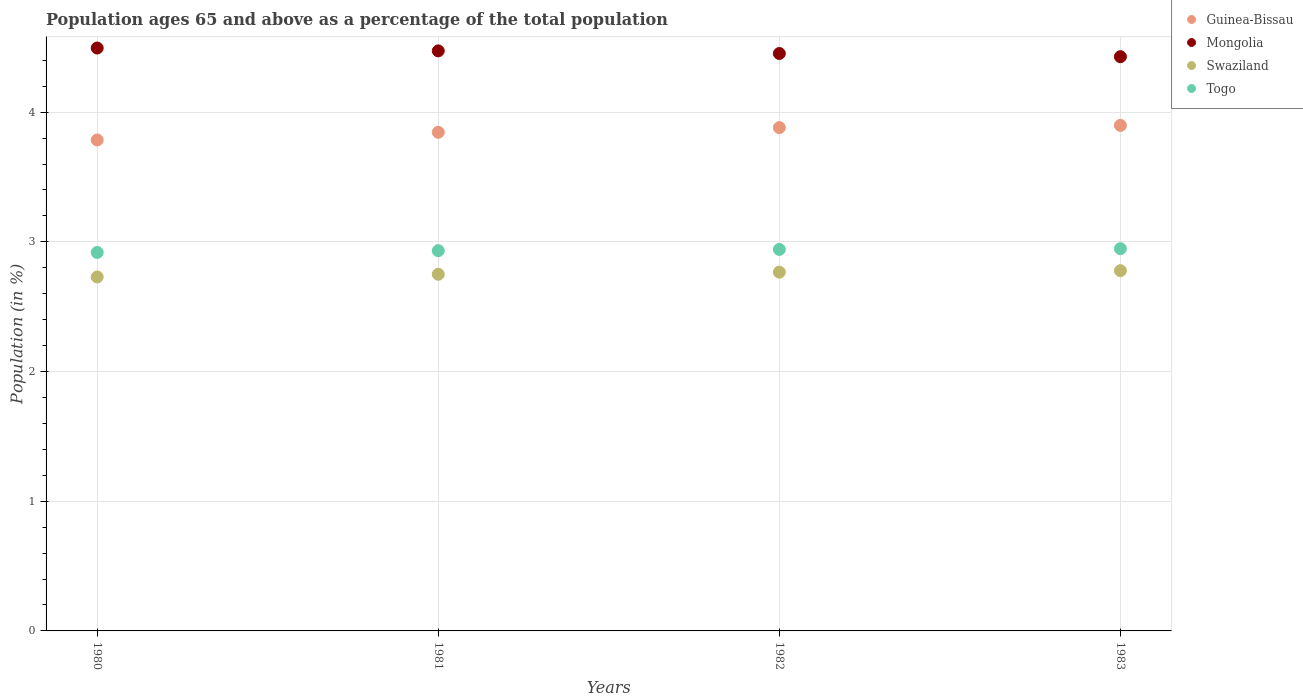What is the percentage of the population ages 65 and above in Togo in 1983?
Your answer should be compact. 2.95. Across all years, what is the maximum percentage of the population ages 65 and above in Swaziland?
Give a very brief answer. 2.78. Across all years, what is the minimum percentage of the population ages 65 and above in Guinea-Bissau?
Offer a terse response. 3.79. In which year was the percentage of the population ages 65 and above in Guinea-Bissau maximum?
Make the answer very short. 1983. In which year was the percentage of the population ages 65 and above in Togo minimum?
Provide a succinct answer. 1980. What is the total percentage of the population ages 65 and above in Togo in the graph?
Offer a very short reply. 11.74. What is the difference between the percentage of the population ages 65 and above in Togo in 1980 and that in 1981?
Your answer should be compact. -0.01. What is the difference between the percentage of the population ages 65 and above in Guinea-Bissau in 1981 and the percentage of the population ages 65 and above in Mongolia in 1982?
Your answer should be compact. -0.61. What is the average percentage of the population ages 65 and above in Swaziland per year?
Give a very brief answer. 2.76. In the year 1980, what is the difference between the percentage of the population ages 65 and above in Swaziland and percentage of the population ages 65 and above in Togo?
Keep it short and to the point. -0.19. In how many years, is the percentage of the population ages 65 and above in Guinea-Bissau greater than 2.8?
Your answer should be compact. 4. What is the ratio of the percentage of the population ages 65 and above in Mongolia in 1980 to that in 1982?
Offer a terse response. 1.01. What is the difference between the highest and the second highest percentage of the population ages 65 and above in Swaziland?
Your answer should be very brief. 0.01. What is the difference between the highest and the lowest percentage of the population ages 65 and above in Swaziland?
Your response must be concise. 0.05. Is it the case that in every year, the sum of the percentage of the population ages 65 and above in Guinea-Bissau and percentage of the population ages 65 and above in Swaziland  is greater than the sum of percentage of the population ages 65 and above in Mongolia and percentage of the population ages 65 and above in Togo?
Your answer should be compact. Yes. Is it the case that in every year, the sum of the percentage of the population ages 65 and above in Mongolia and percentage of the population ages 65 and above in Swaziland  is greater than the percentage of the population ages 65 and above in Guinea-Bissau?
Make the answer very short. Yes. Does the percentage of the population ages 65 and above in Mongolia monotonically increase over the years?
Provide a short and direct response. No. Is the percentage of the population ages 65 and above in Swaziland strictly less than the percentage of the population ages 65 and above in Mongolia over the years?
Your response must be concise. Yes. Are the values on the major ticks of Y-axis written in scientific E-notation?
Provide a short and direct response. No. What is the title of the graph?
Offer a terse response. Population ages 65 and above as a percentage of the total population. What is the label or title of the X-axis?
Offer a terse response. Years. What is the label or title of the Y-axis?
Ensure brevity in your answer.  Population (in %). What is the Population (in %) of Guinea-Bissau in 1980?
Give a very brief answer. 3.79. What is the Population (in %) in Mongolia in 1980?
Provide a short and direct response. 4.49. What is the Population (in %) in Swaziland in 1980?
Offer a terse response. 2.73. What is the Population (in %) in Togo in 1980?
Offer a very short reply. 2.92. What is the Population (in %) of Guinea-Bissau in 1981?
Make the answer very short. 3.84. What is the Population (in %) in Mongolia in 1981?
Your answer should be very brief. 4.47. What is the Population (in %) of Swaziland in 1981?
Provide a succinct answer. 2.75. What is the Population (in %) of Togo in 1981?
Your answer should be compact. 2.93. What is the Population (in %) in Guinea-Bissau in 1982?
Give a very brief answer. 3.88. What is the Population (in %) in Mongolia in 1982?
Make the answer very short. 4.45. What is the Population (in %) in Swaziland in 1982?
Your answer should be compact. 2.77. What is the Population (in %) of Togo in 1982?
Offer a terse response. 2.94. What is the Population (in %) in Guinea-Bissau in 1983?
Your response must be concise. 3.9. What is the Population (in %) in Mongolia in 1983?
Keep it short and to the point. 4.43. What is the Population (in %) in Swaziland in 1983?
Provide a succinct answer. 2.78. What is the Population (in %) in Togo in 1983?
Your response must be concise. 2.95. Across all years, what is the maximum Population (in %) of Guinea-Bissau?
Offer a very short reply. 3.9. Across all years, what is the maximum Population (in %) of Mongolia?
Keep it short and to the point. 4.49. Across all years, what is the maximum Population (in %) in Swaziland?
Ensure brevity in your answer.  2.78. Across all years, what is the maximum Population (in %) in Togo?
Keep it short and to the point. 2.95. Across all years, what is the minimum Population (in %) of Guinea-Bissau?
Offer a terse response. 3.79. Across all years, what is the minimum Population (in %) of Mongolia?
Keep it short and to the point. 4.43. Across all years, what is the minimum Population (in %) in Swaziland?
Give a very brief answer. 2.73. Across all years, what is the minimum Population (in %) in Togo?
Make the answer very short. 2.92. What is the total Population (in %) in Guinea-Bissau in the graph?
Ensure brevity in your answer.  15.41. What is the total Population (in %) of Mongolia in the graph?
Offer a terse response. 17.85. What is the total Population (in %) in Swaziland in the graph?
Your answer should be very brief. 11.02. What is the total Population (in %) in Togo in the graph?
Offer a very short reply. 11.74. What is the difference between the Population (in %) in Guinea-Bissau in 1980 and that in 1981?
Your answer should be compact. -0.06. What is the difference between the Population (in %) of Mongolia in 1980 and that in 1981?
Make the answer very short. 0.02. What is the difference between the Population (in %) in Swaziland in 1980 and that in 1981?
Your response must be concise. -0.02. What is the difference between the Population (in %) in Togo in 1980 and that in 1981?
Offer a very short reply. -0.01. What is the difference between the Population (in %) of Guinea-Bissau in 1980 and that in 1982?
Provide a short and direct response. -0.1. What is the difference between the Population (in %) of Mongolia in 1980 and that in 1982?
Your response must be concise. 0.04. What is the difference between the Population (in %) in Swaziland in 1980 and that in 1982?
Your answer should be very brief. -0.04. What is the difference between the Population (in %) in Togo in 1980 and that in 1982?
Ensure brevity in your answer.  -0.02. What is the difference between the Population (in %) in Guinea-Bissau in 1980 and that in 1983?
Provide a succinct answer. -0.11. What is the difference between the Population (in %) in Mongolia in 1980 and that in 1983?
Ensure brevity in your answer.  0.07. What is the difference between the Population (in %) in Swaziland in 1980 and that in 1983?
Your answer should be compact. -0.05. What is the difference between the Population (in %) in Togo in 1980 and that in 1983?
Make the answer very short. -0.03. What is the difference between the Population (in %) of Guinea-Bissau in 1981 and that in 1982?
Your answer should be compact. -0.04. What is the difference between the Population (in %) in Mongolia in 1981 and that in 1982?
Keep it short and to the point. 0.02. What is the difference between the Population (in %) of Swaziland in 1981 and that in 1982?
Your answer should be compact. -0.02. What is the difference between the Population (in %) of Togo in 1981 and that in 1982?
Give a very brief answer. -0.01. What is the difference between the Population (in %) in Guinea-Bissau in 1981 and that in 1983?
Keep it short and to the point. -0.05. What is the difference between the Population (in %) in Mongolia in 1981 and that in 1983?
Offer a very short reply. 0.04. What is the difference between the Population (in %) of Swaziland in 1981 and that in 1983?
Your answer should be very brief. -0.03. What is the difference between the Population (in %) of Togo in 1981 and that in 1983?
Provide a short and direct response. -0.02. What is the difference between the Population (in %) of Guinea-Bissau in 1982 and that in 1983?
Offer a terse response. -0.02. What is the difference between the Population (in %) in Mongolia in 1982 and that in 1983?
Your answer should be compact. 0.02. What is the difference between the Population (in %) in Swaziland in 1982 and that in 1983?
Make the answer very short. -0.01. What is the difference between the Population (in %) in Togo in 1982 and that in 1983?
Provide a succinct answer. -0.01. What is the difference between the Population (in %) in Guinea-Bissau in 1980 and the Population (in %) in Mongolia in 1981?
Your answer should be compact. -0.69. What is the difference between the Population (in %) of Guinea-Bissau in 1980 and the Population (in %) of Swaziland in 1981?
Your answer should be very brief. 1.04. What is the difference between the Population (in %) of Guinea-Bissau in 1980 and the Population (in %) of Togo in 1981?
Give a very brief answer. 0.85. What is the difference between the Population (in %) in Mongolia in 1980 and the Population (in %) in Swaziland in 1981?
Offer a terse response. 1.74. What is the difference between the Population (in %) of Mongolia in 1980 and the Population (in %) of Togo in 1981?
Your answer should be very brief. 1.56. What is the difference between the Population (in %) in Swaziland in 1980 and the Population (in %) in Togo in 1981?
Your response must be concise. -0.2. What is the difference between the Population (in %) in Guinea-Bissau in 1980 and the Population (in %) in Mongolia in 1982?
Offer a very short reply. -0.67. What is the difference between the Population (in %) of Guinea-Bissau in 1980 and the Population (in %) of Swaziland in 1982?
Your response must be concise. 1.02. What is the difference between the Population (in %) of Guinea-Bissau in 1980 and the Population (in %) of Togo in 1982?
Keep it short and to the point. 0.84. What is the difference between the Population (in %) in Mongolia in 1980 and the Population (in %) in Swaziland in 1982?
Give a very brief answer. 1.73. What is the difference between the Population (in %) of Mongolia in 1980 and the Population (in %) of Togo in 1982?
Provide a succinct answer. 1.55. What is the difference between the Population (in %) in Swaziland in 1980 and the Population (in %) in Togo in 1982?
Ensure brevity in your answer.  -0.21. What is the difference between the Population (in %) of Guinea-Bissau in 1980 and the Population (in %) of Mongolia in 1983?
Give a very brief answer. -0.64. What is the difference between the Population (in %) in Guinea-Bissau in 1980 and the Population (in %) in Swaziland in 1983?
Offer a very short reply. 1.01. What is the difference between the Population (in %) of Guinea-Bissau in 1980 and the Population (in %) of Togo in 1983?
Give a very brief answer. 0.84. What is the difference between the Population (in %) of Mongolia in 1980 and the Population (in %) of Swaziland in 1983?
Keep it short and to the point. 1.72. What is the difference between the Population (in %) of Mongolia in 1980 and the Population (in %) of Togo in 1983?
Your answer should be very brief. 1.55. What is the difference between the Population (in %) of Swaziland in 1980 and the Population (in %) of Togo in 1983?
Ensure brevity in your answer.  -0.22. What is the difference between the Population (in %) in Guinea-Bissau in 1981 and the Population (in %) in Mongolia in 1982?
Offer a very short reply. -0.61. What is the difference between the Population (in %) in Guinea-Bissau in 1981 and the Population (in %) in Swaziland in 1982?
Offer a terse response. 1.08. What is the difference between the Population (in %) in Guinea-Bissau in 1981 and the Population (in %) in Togo in 1982?
Keep it short and to the point. 0.9. What is the difference between the Population (in %) of Mongolia in 1981 and the Population (in %) of Swaziland in 1982?
Ensure brevity in your answer.  1.71. What is the difference between the Population (in %) in Mongolia in 1981 and the Population (in %) in Togo in 1982?
Give a very brief answer. 1.53. What is the difference between the Population (in %) of Swaziland in 1981 and the Population (in %) of Togo in 1982?
Your answer should be compact. -0.19. What is the difference between the Population (in %) in Guinea-Bissau in 1981 and the Population (in %) in Mongolia in 1983?
Provide a succinct answer. -0.58. What is the difference between the Population (in %) in Guinea-Bissau in 1981 and the Population (in %) in Swaziland in 1983?
Offer a terse response. 1.07. What is the difference between the Population (in %) in Guinea-Bissau in 1981 and the Population (in %) in Togo in 1983?
Your response must be concise. 0.9. What is the difference between the Population (in %) in Mongolia in 1981 and the Population (in %) in Swaziland in 1983?
Provide a succinct answer. 1.69. What is the difference between the Population (in %) in Mongolia in 1981 and the Population (in %) in Togo in 1983?
Your response must be concise. 1.53. What is the difference between the Population (in %) in Swaziland in 1981 and the Population (in %) in Togo in 1983?
Ensure brevity in your answer.  -0.2. What is the difference between the Population (in %) in Guinea-Bissau in 1982 and the Population (in %) in Mongolia in 1983?
Your answer should be very brief. -0.55. What is the difference between the Population (in %) in Guinea-Bissau in 1982 and the Population (in %) in Swaziland in 1983?
Your answer should be compact. 1.1. What is the difference between the Population (in %) of Guinea-Bissau in 1982 and the Population (in %) of Togo in 1983?
Keep it short and to the point. 0.93. What is the difference between the Population (in %) of Mongolia in 1982 and the Population (in %) of Swaziland in 1983?
Your response must be concise. 1.67. What is the difference between the Population (in %) of Mongolia in 1982 and the Population (in %) of Togo in 1983?
Your answer should be compact. 1.5. What is the difference between the Population (in %) of Swaziland in 1982 and the Population (in %) of Togo in 1983?
Keep it short and to the point. -0.18. What is the average Population (in %) of Guinea-Bissau per year?
Offer a terse response. 3.85. What is the average Population (in %) in Mongolia per year?
Offer a very short reply. 4.46. What is the average Population (in %) in Swaziland per year?
Offer a very short reply. 2.76. What is the average Population (in %) in Togo per year?
Keep it short and to the point. 2.94. In the year 1980, what is the difference between the Population (in %) in Guinea-Bissau and Population (in %) in Mongolia?
Provide a short and direct response. -0.71. In the year 1980, what is the difference between the Population (in %) of Guinea-Bissau and Population (in %) of Swaziland?
Offer a very short reply. 1.06. In the year 1980, what is the difference between the Population (in %) of Guinea-Bissau and Population (in %) of Togo?
Your answer should be compact. 0.87. In the year 1980, what is the difference between the Population (in %) in Mongolia and Population (in %) in Swaziland?
Provide a short and direct response. 1.77. In the year 1980, what is the difference between the Population (in %) of Mongolia and Population (in %) of Togo?
Provide a succinct answer. 1.58. In the year 1980, what is the difference between the Population (in %) of Swaziland and Population (in %) of Togo?
Ensure brevity in your answer.  -0.19. In the year 1981, what is the difference between the Population (in %) of Guinea-Bissau and Population (in %) of Mongolia?
Ensure brevity in your answer.  -0.63. In the year 1981, what is the difference between the Population (in %) of Guinea-Bissau and Population (in %) of Swaziland?
Your response must be concise. 1.09. In the year 1981, what is the difference between the Population (in %) of Guinea-Bissau and Population (in %) of Togo?
Provide a short and direct response. 0.91. In the year 1981, what is the difference between the Population (in %) in Mongolia and Population (in %) in Swaziland?
Give a very brief answer. 1.72. In the year 1981, what is the difference between the Population (in %) in Mongolia and Population (in %) in Togo?
Ensure brevity in your answer.  1.54. In the year 1981, what is the difference between the Population (in %) of Swaziland and Population (in %) of Togo?
Ensure brevity in your answer.  -0.18. In the year 1982, what is the difference between the Population (in %) of Guinea-Bissau and Population (in %) of Mongolia?
Offer a terse response. -0.57. In the year 1982, what is the difference between the Population (in %) in Guinea-Bissau and Population (in %) in Swaziland?
Provide a short and direct response. 1.11. In the year 1982, what is the difference between the Population (in %) in Guinea-Bissau and Population (in %) in Togo?
Keep it short and to the point. 0.94. In the year 1982, what is the difference between the Population (in %) of Mongolia and Population (in %) of Swaziland?
Your answer should be compact. 1.69. In the year 1982, what is the difference between the Population (in %) of Mongolia and Population (in %) of Togo?
Your answer should be compact. 1.51. In the year 1982, what is the difference between the Population (in %) of Swaziland and Population (in %) of Togo?
Provide a succinct answer. -0.18. In the year 1983, what is the difference between the Population (in %) of Guinea-Bissau and Population (in %) of Mongolia?
Provide a succinct answer. -0.53. In the year 1983, what is the difference between the Population (in %) in Guinea-Bissau and Population (in %) in Swaziland?
Provide a succinct answer. 1.12. In the year 1983, what is the difference between the Population (in %) in Guinea-Bissau and Population (in %) in Togo?
Provide a succinct answer. 0.95. In the year 1983, what is the difference between the Population (in %) in Mongolia and Population (in %) in Swaziland?
Your answer should be very brief. 1.65. In the year 1983, what is the difference between the Population (in %) of Mongolia and Population (in %) of Togo?
Provide a succinct answer. 1.48. In the year 1983, what is the difference between the Population (in %) of Swaziland and Population (in %) of Togo?
Your answer should be very brief. -0.17. What is the ratio of the Population (in %) of Guinea-Bissau in 1980 to that in 1981?
Offer a very short reply. 0.98. What is the ratio of the Population (in %) in Mongolia in 1980 to that in 1981?
Your response must be concise. 1. What is the ratio of the Population (in %) of Swaziland in 1980 to that in 1981?
Your answer should be compact. 0.99. What is the ratio of the Population (in %) in Togo in 1980 to that in 1981?
Make the answer very short. 1. What is the ratio of the Population (in %) of Guinea-Bissau in 1980 to that in 1982?
Ensure brevity in your answer.  0.98. What is the ratio of the Population (in %) in Mongolia in 1980 to that in 1982?
Provide a short and direct response. 1.01. What is the ratio of the Population (in %) in Swaziland in 1980 to that in 1982?
Your response must be concise. 0.99. What is the ratio of the Population (in %) in Guinea-Bissau in 1980 to that in 1983?
Make the answer very short. 0.97. What is the ratio of the Population (in %) of Mongolia in 1980 to that in 1983?
Your response must be concise. 1.02. What is the ratio of the Population (in %) of Swaziland in 1980 to that in 1983?
Ensure brevity in your answer.  0.98. What is the ratio of the Population (in %) in Togo in 1980 to that in 1983?
Keep it short and to the point. 0.99. What is the ratio of the Population (in %) in Guinea-Bissau in 1981 to that in 1982?
Your response must be concise. 0.99. What is the ratio of the Population (in %) of Mongolia in 1981 to that in 1982?
Offer a very short reply. 1. What is the ratio of the Population (in %) of Swaziland in 1981 to that in 1982?
Your answer should be very brief. 0.99. What is the ratio of the Population (in %) of Togo in 1981 to that in 1982?
Your answer should be very brief. 1. What is the ratio of the Population (in %) of Guinea-Bissau in 1981 to that in 1983?
Offer a very short reply. 0.99. What is the ratio of the Population (in %) in Togo in 1981 to that in 1983?
Keep it short and to the point. 0.99. What is the ratio of the Population (in %) of Mongolia in 1982 to that in 1983?
Ensure brevity in your answer.  1.01. What is the ratio of the Population (in %) of Togo in 1982 to that in 1983?
Your response must be concise. 1. What is the difference between the highest and the second highest Population (in %) in Guinea-Bissau?
Offer a terse response. 0.02. What is the difference between the highest and the second highest Population (in %) of Mongolia?
Your response must be concise. 0.02. What is the difference between the highest and the second highest Population (in %) of Swaziland?
Offer a terse response. 0.01. What is the difference between the highest and the second highest Population (in %) in Togo?
Offer a terse response. 0.01. What is the difference between the highest and the lowest Population (in %) of Guinea-Bissau?
Your response must be concise. 0.11. What is the difference between the highest and the lowest Population (in %) of Mongolia?
Give a very brief answer. 0.07. What is the difference between the highest and the lowest Population (in %) in Swaziland?
Your answer should be compact. 0.05. What is the difference between the highest and the lowest Population (in %) of Togo?
Offer a very short reply. 0.03. 